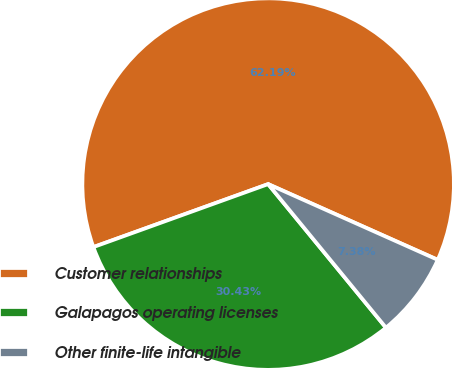<chart> <loc_0><loc_0><loc_500><loc_500><pie_chart><fcel>Customer relationships<fcel>Galapagos operating licenses<fcel>Other finite-life intangible<nl><fcel>62.19%<fcel>30.43%<fcel>7.38%<nl></chart> 